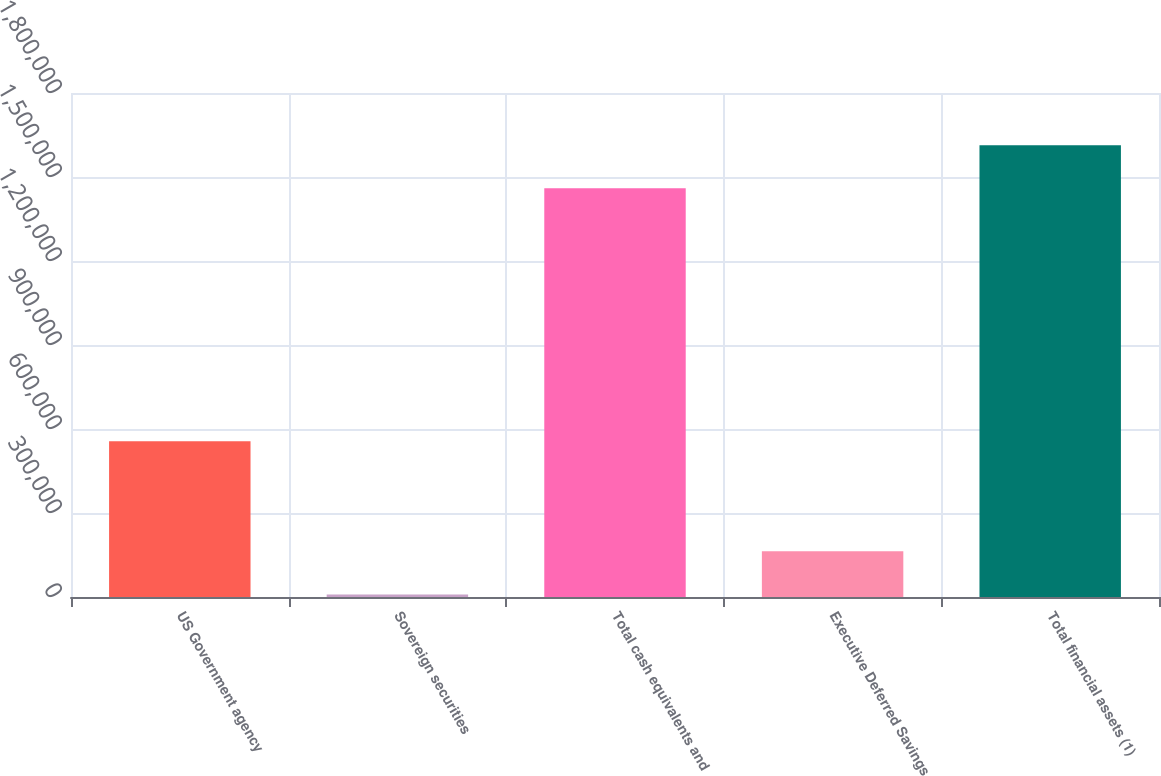Convert chart to OTSL. <chart><loc_0><loc_0><loc_500><loc_500><bar_chart><fcel>US Government agency<fcel>Sovereign securities<fcel>Total cash equivalents and<fcel>Executive Deferred Savings<fcel>Total financial assets (1)<nl><fcel>556019<fcel>8976<fcel>1.45944e+06<fcel>163142<fcel>1.6136e+06<nl></chart> 